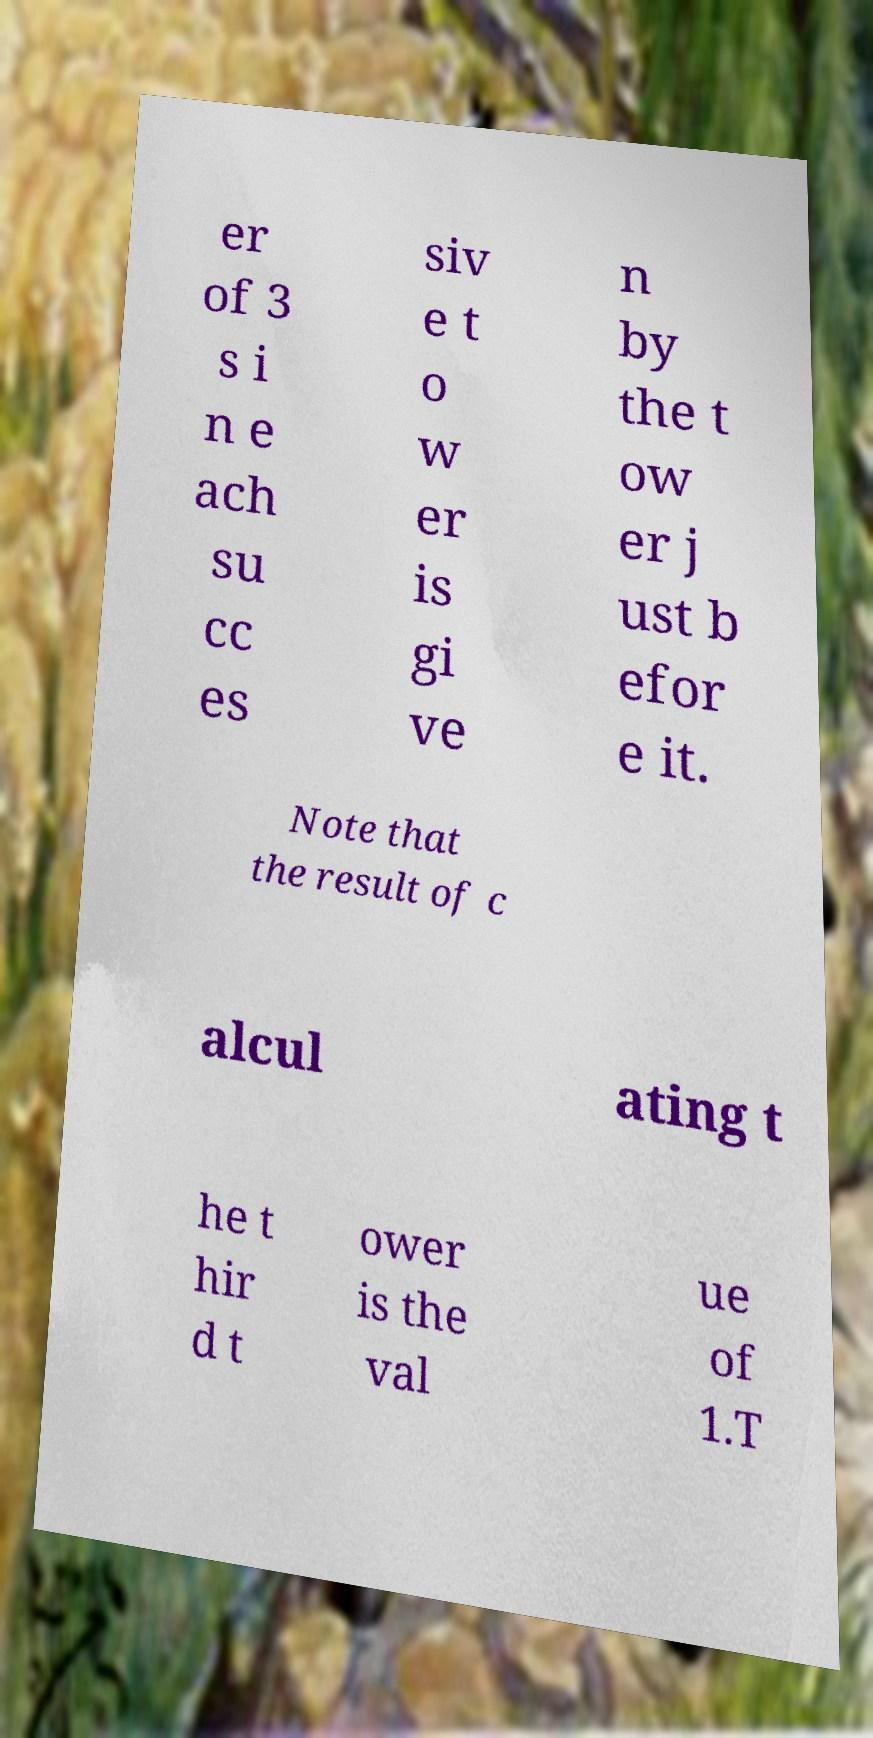I need the written content from this picture converted into text. Can you do that? er of 3 s i n e ach su cc es siv e t o w er is gi ve n by the t ow er j ust b efor e it. Note that the result of c alcul ating t he t hir d t ower is the val ue of 1.T 